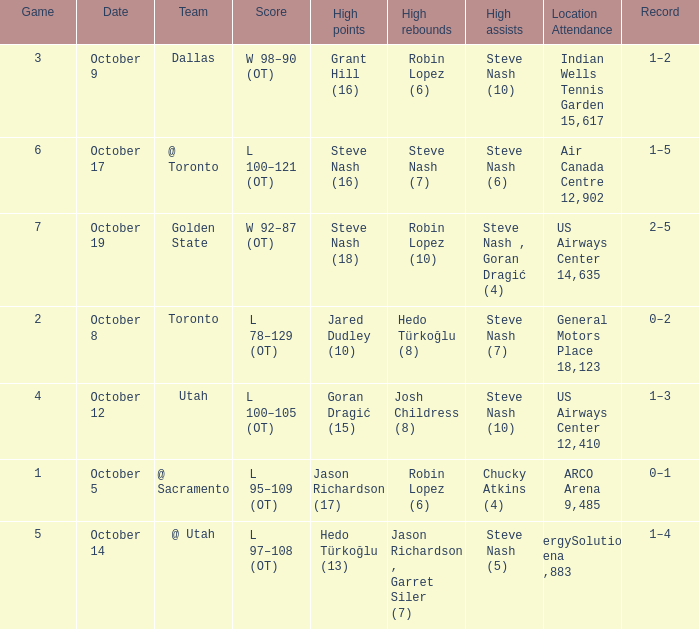How many games had Robin Lopez (10) for the most rebounds? 1.0. 